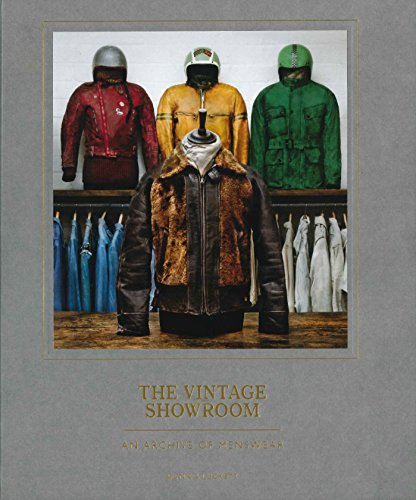What impact has vintage fashion had on modern clothing styles? Vintage fashion significantly influences modern clothing by reintroducing classical elements with a modern twist, helping shape contemporary fashion trends. Many modern designers draw inspiration from past styles to create nostalgic yet innovative new looks. 